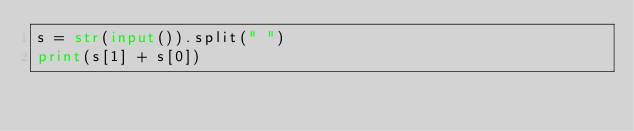Convert code to text. <code><loc_0><loc_0><loc_500><loc_500><_Python_>s = str(input()).split(" ")
print(s[1] + s[0])</code> 